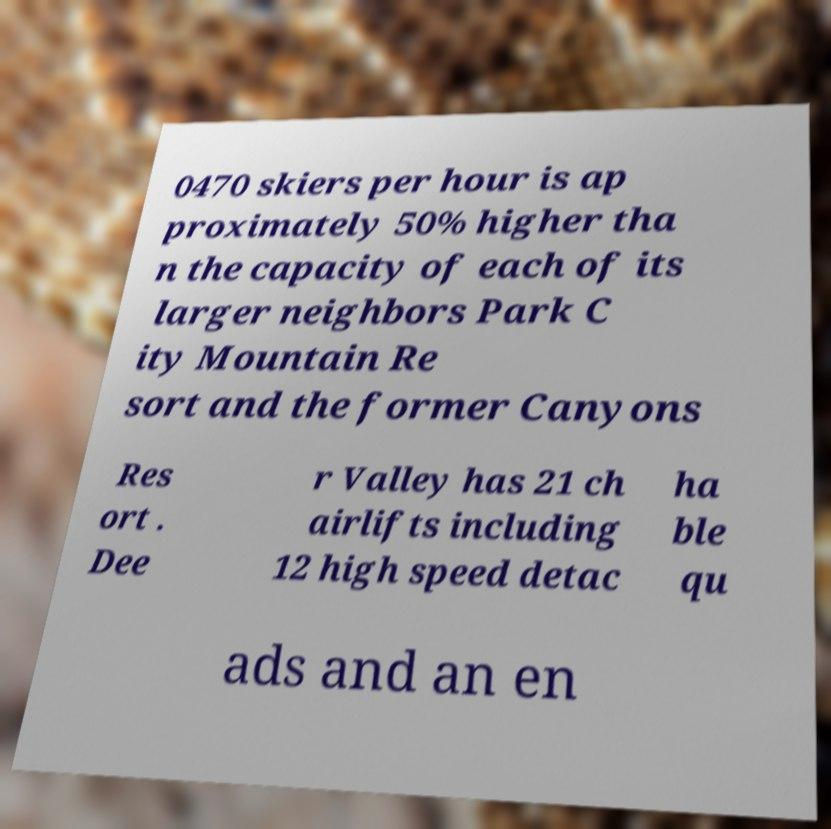Please identify and transcribe the text found in this image. 0470 skiers per hour is ap proximately 50% higher tha n the capacity of each of its larger neighbors Park C ity Mountain Re sort and the former Canyons Res ort . Dee r Valley has 21 ch airlifts including 12 high speed detac ha ble qu ads and an en 